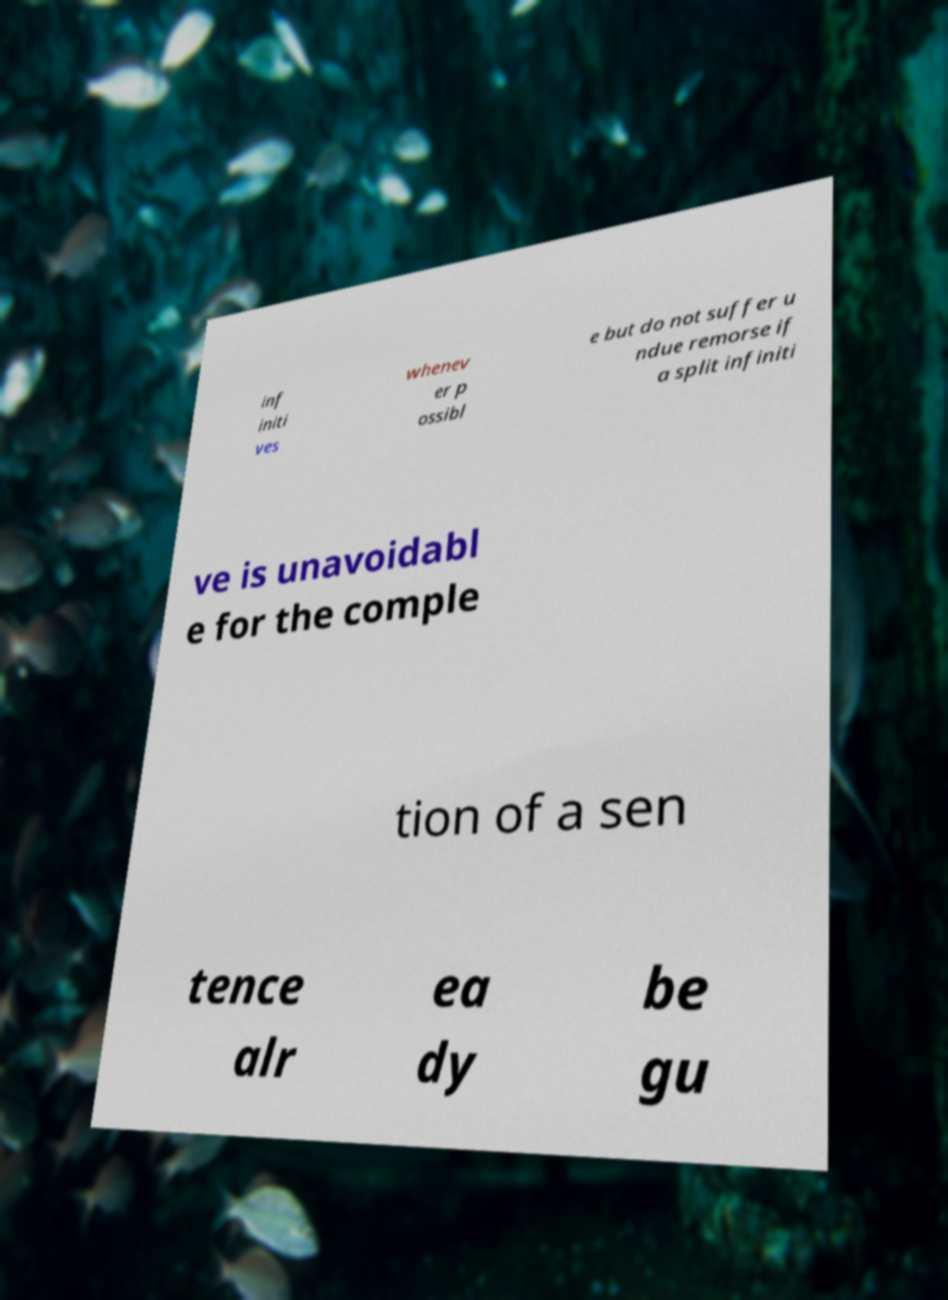What messages or text are displayed in this image? I need them in a readable, typed format. inf initi ves whenev er p ossibl e but do not suffer u ndue remorse if a split infiniti ve is unavoidabl e for the comple tion of a sen tence alr ea dy be gu 